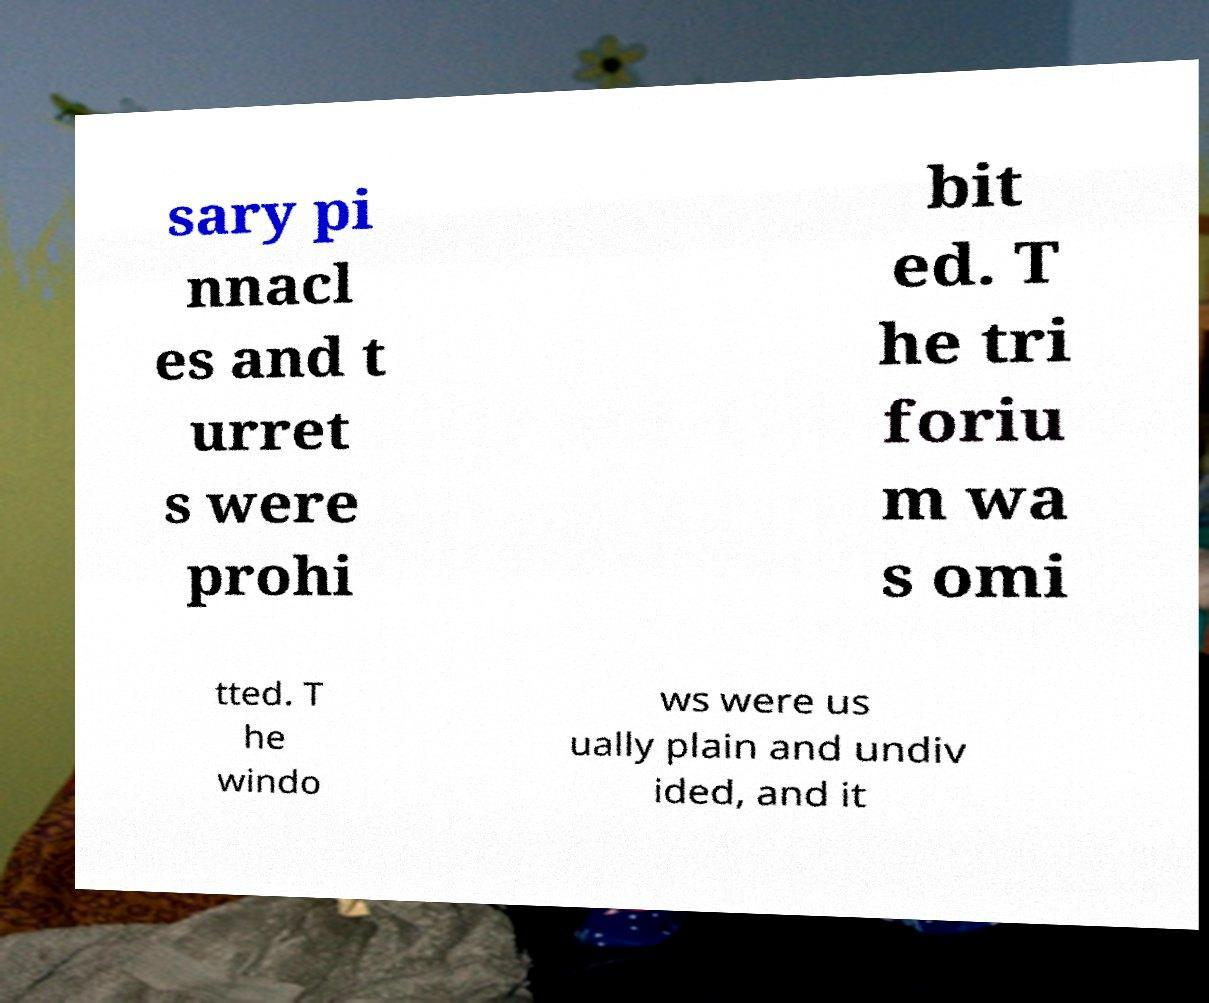For documentation purposes, I need the text within this image transcribed. Could you provide that? sary pi nnacl es and t urret s were prohi bit ed. T he tri foriu m wa s omi tted. T he windo ws were us ually plain and undiv ided, and it 